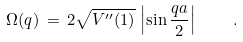Convert formula to latex. <formula><loc_0><loc_0><loc_500><loc_500>\Omega ( q ) \, = \, 2 \sqrt { V ^ { \prime \prime } ( 1 ) } \, \left | \sin \frac { q a } { 2 } \right | \quad .</formula> 